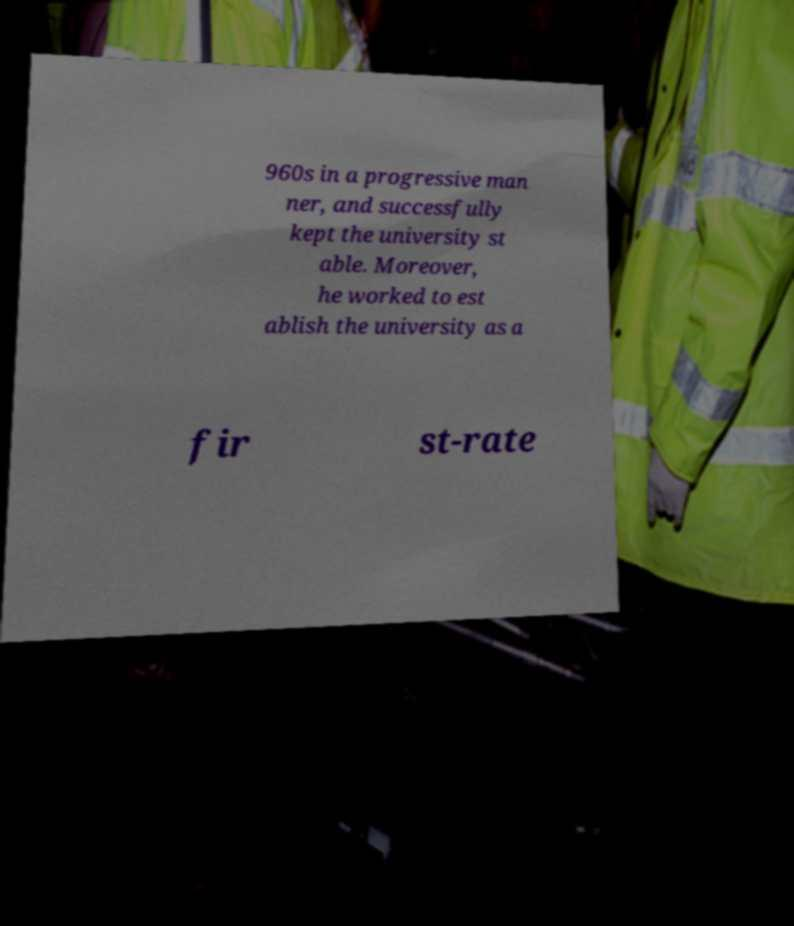Please identify and transcribe the text found in this image. 960s in a progressive man ner, and successfully kept the university st able. Moreover, he worked to est ablish the university as a fir st-rate 